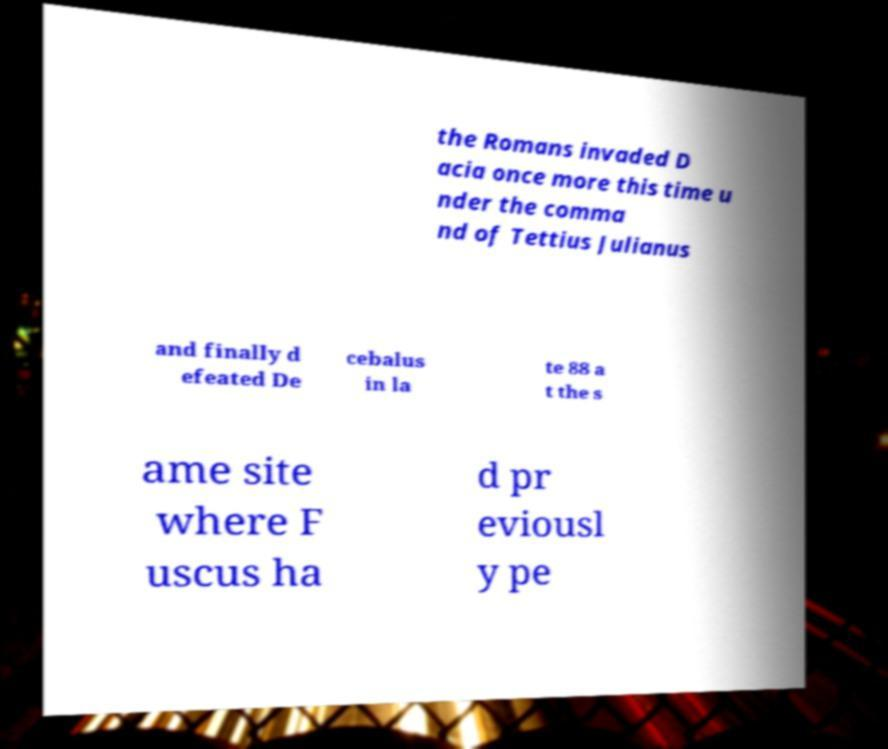There's text embedded in this image that I need extracted. Can you transcribe it verbatim? the Romans invaded D acia once more this time u nder the comma nd of Tettius Julianus and finally d efeated De cebalus in la te 88 a t the s ame site where F uscus ha d pr eviousl y pe 